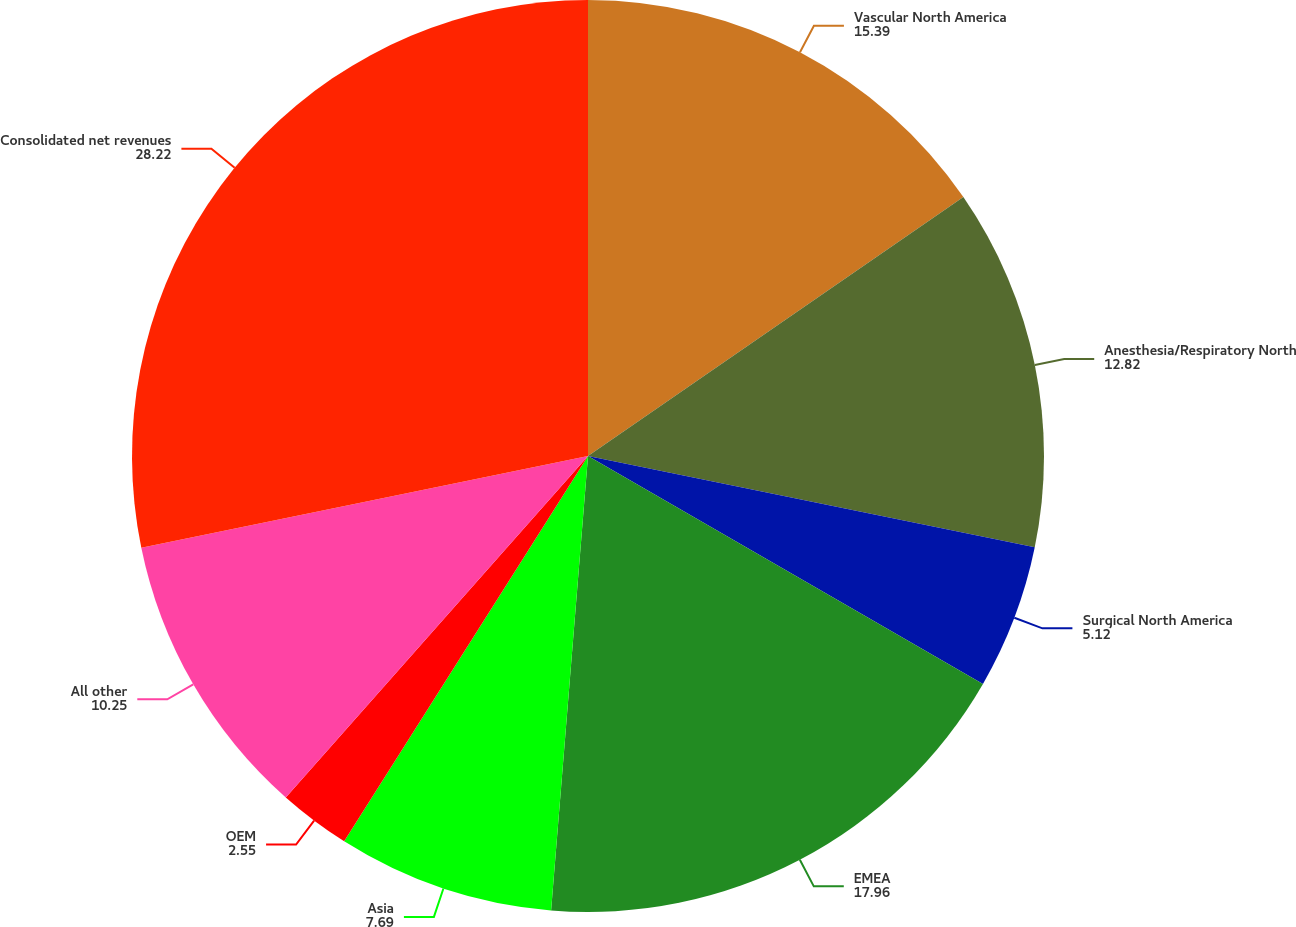<chart> <loc_0><loc_0><loc_500><loc_500><pie_chart><fcel>Vascular North America<fcel>Anesthesia/Respiratory North<fcel>Surgical North America<fcel>EMEA<fcel>Asia<fcel>OEM<fcel>All other<fcel>Consolidated net revenues<nl><fcel>15.39%<fcel>12.82%<fcel>5.12%<fcel>17.96%<fcel>7.69%<fcel>2.55%<fcel>10.25%<fcel>28.22%<nl></chart> 